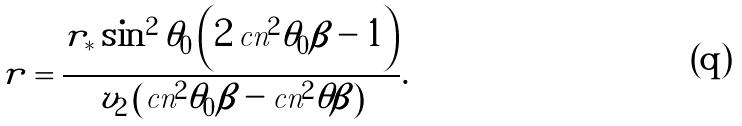<formula> <loc_0><loc_0><loc_500><loc_500>r = \frac { r _ { * } \sin ^ { 2 } \theta _ { 0 } \left ( 2 \, \text {cn} ^ { 2 } \theta _ { 0 } \beta - 1 \right ) } { v _ { 2 } \left ( \text {cn} ^ { 2 } \theta _ { 0 } \beta - \text {cn} ^ { 2 } \theta \beta \right ) } .</formula> 